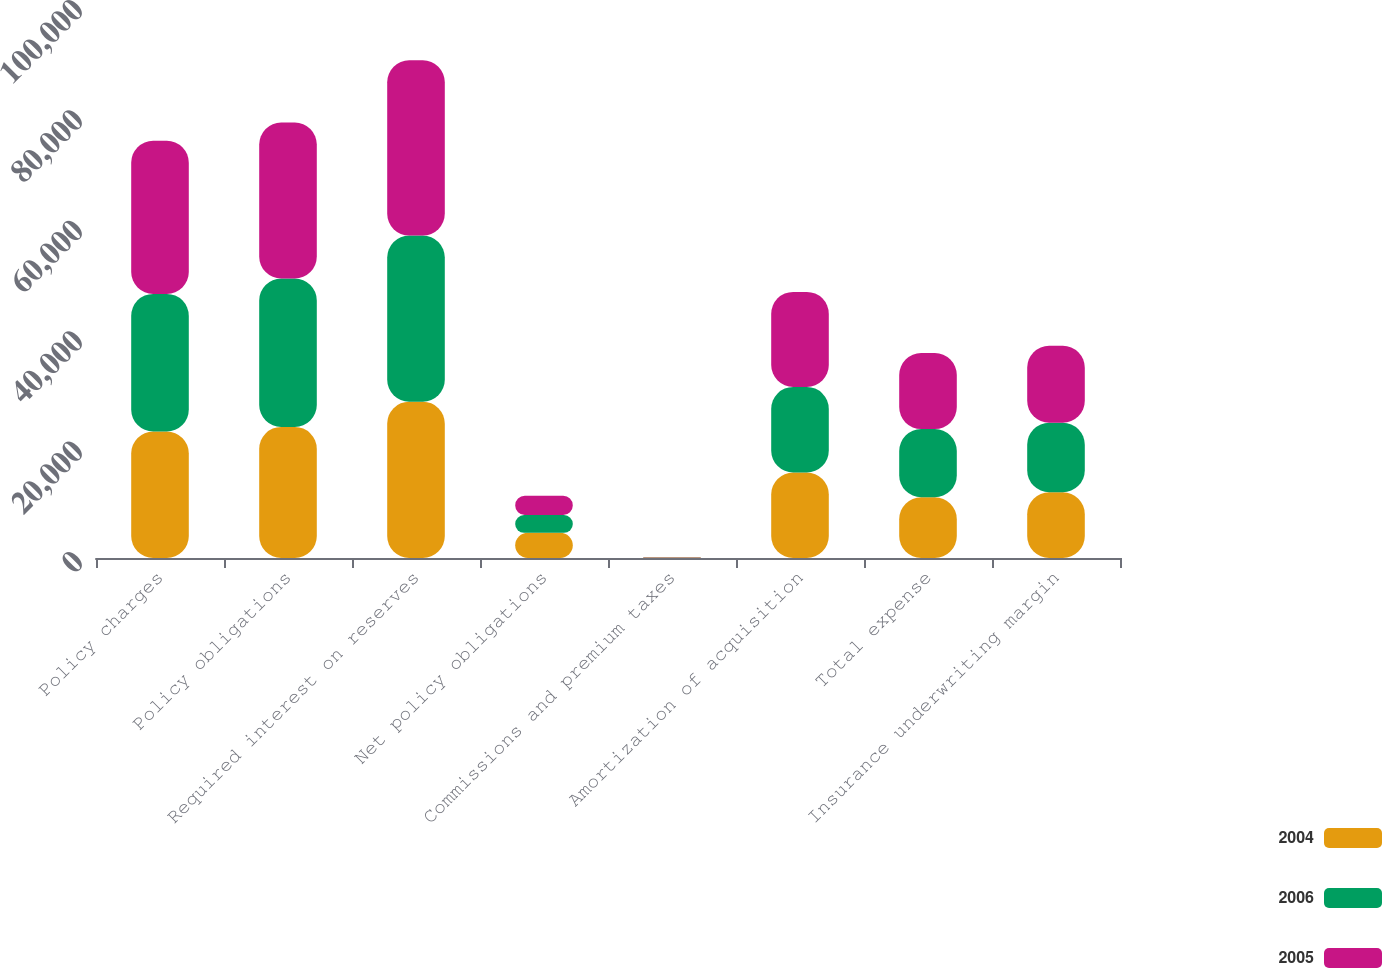Convert chart. <chart><loc_0><loc_0><loc_500><loc_500><stacked_bar_chart><ecel><fcel>Policy charges<fcel>Policy obligations<fcel>Required interest on reserves<fcel>Net policy obligations<fcel>Commissions and premium taxes<fcel>Amortization of acquisition<fcel>Total expense<fcel>Insurance underwriting margin<nl><fcel>2004<fcel>22914<fcel>23743<fcel>28318<fcel>4575<fcel>88<fcel>15486<fcel>10999<fcel>11915<nl><fcel>2006<fcel>24929<fcel>26888<fcel>30092<fcel>3204<fcel>49<fcel>15504<fcel>12349<fcel>12580<nl><fcel>2005<fcel>27744<fcel>28248<fcel>31740<fcel>3492<fcel>61<fcel>17211<fcel>13780<fcel>13964<nl></chart> 